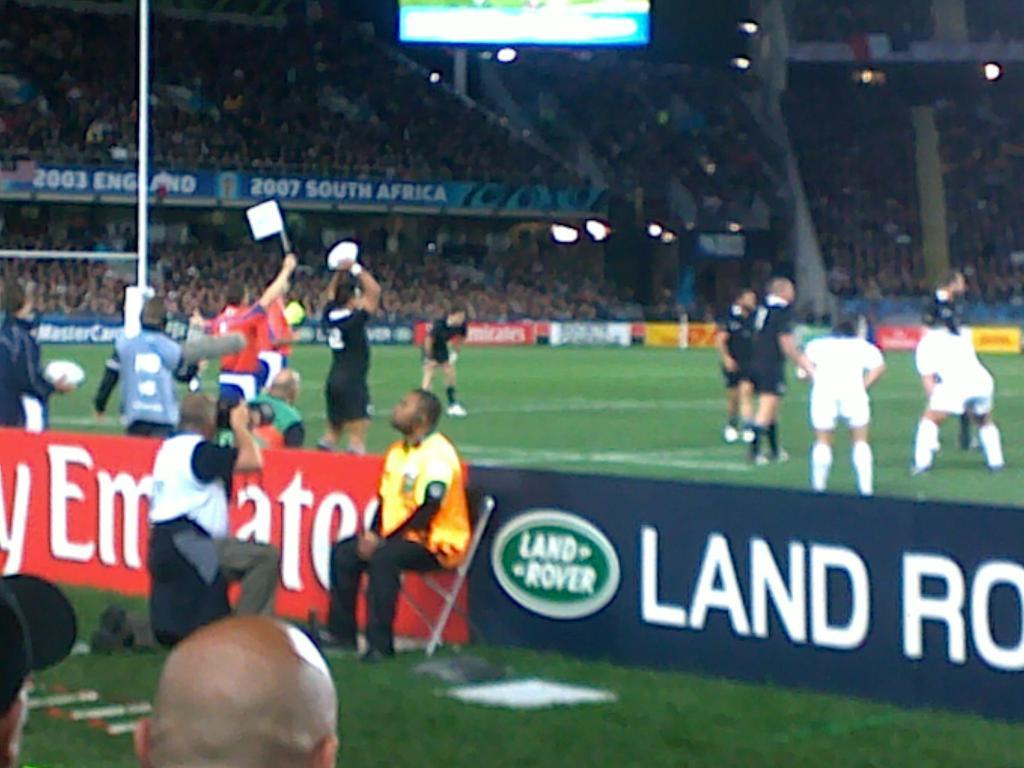What car company advertises at this stadium?
Provide a succinct answer. Land rover. Who is a sponsor?
Your answer should be compact. Land rover. 